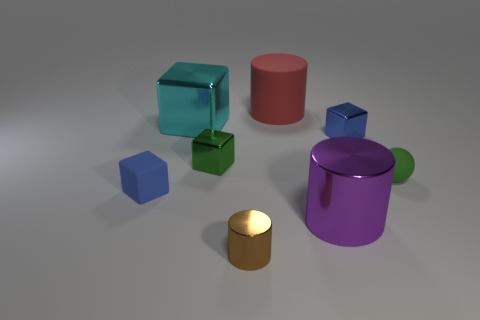Subtract all gray blocks. Subtract all green cylinders. How many blocks are left? 4 Add 2 green balls. How many objects exist? 10 Subtract all cylinders. How many objects are left? 5 Add 4 brown shiny cylinders. How many brown shiny cylinders exist? 5 Subtract 0 red cubes. How many objects are left? 8 Subtract all gray blocks. Subtract all small brown things. How many objects are left? 7 Add 3 small blue metal cubes. How many small blue metal cubes are left? 4 